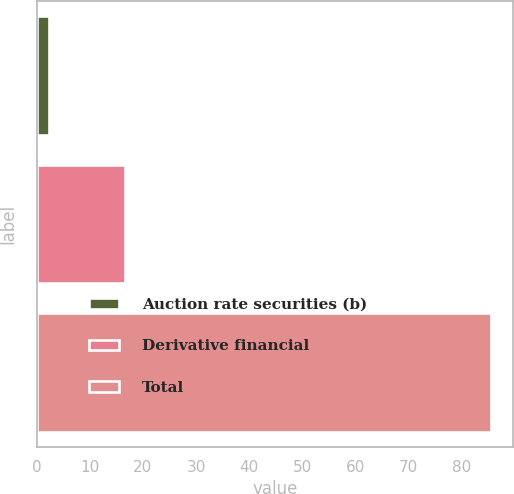Convert chart. <chart><loc_0><loc_0><loc_500><loc_500><bar_chart><fcel>Auction rate securities (b)<fcel>Derivative financial<fcel>Total<nl><fcel>2.3<fcel>16.6<fcel>85.4<nl></chart> 